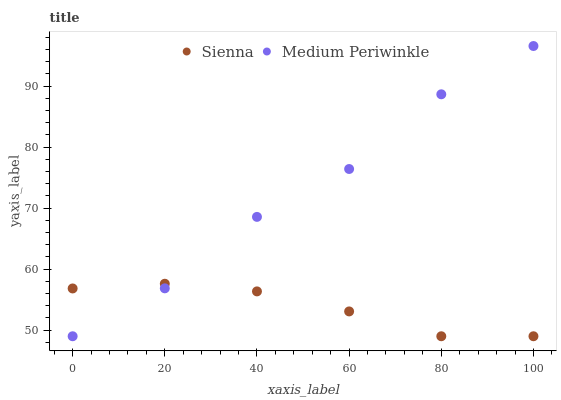Does Sienna have the minimum area under the curve?
Answer yes or no. Yes. Does Medium Periwinkle have the maximum area under the curve?
Answer yes or no. Yes. Does Medium Periwinkle have the minimum area under the curve?
Answer yes or no. No. Is Sienna the smoothest?
Answer yes or no. Yes. Is Medium Periwinkle the roughest?
Answer yes or no. Yes. Is Medium Periwinkle the smoothest?
Answer yes or no. No. Does Sienna have the lowest value?
Answer yes or no. Yes. Does Medium Periwinkle have the highest value?
Answer yes or no. Yes. Does Sienna intersect Medium Periwinkle?
Answer yes or no. Yes. Is Sienna less than Medium Periwinkle?
Answer yes or no. No. Is Sienna greater than Medium Periwinkle?
Answer yes or no. No. 